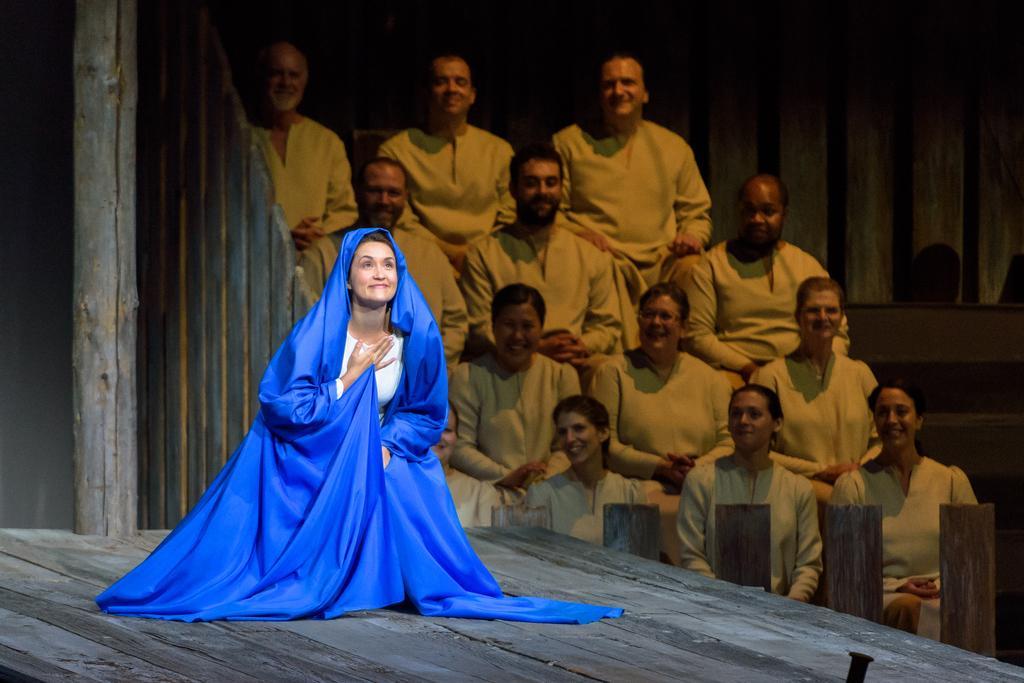Could you give a brief overview of what you see in this image? This picture shows few people are seated and all of them light brown color dresses and we see a woman seated on her knees on the dais and she wore a blue color cloth with a smile on her face. 